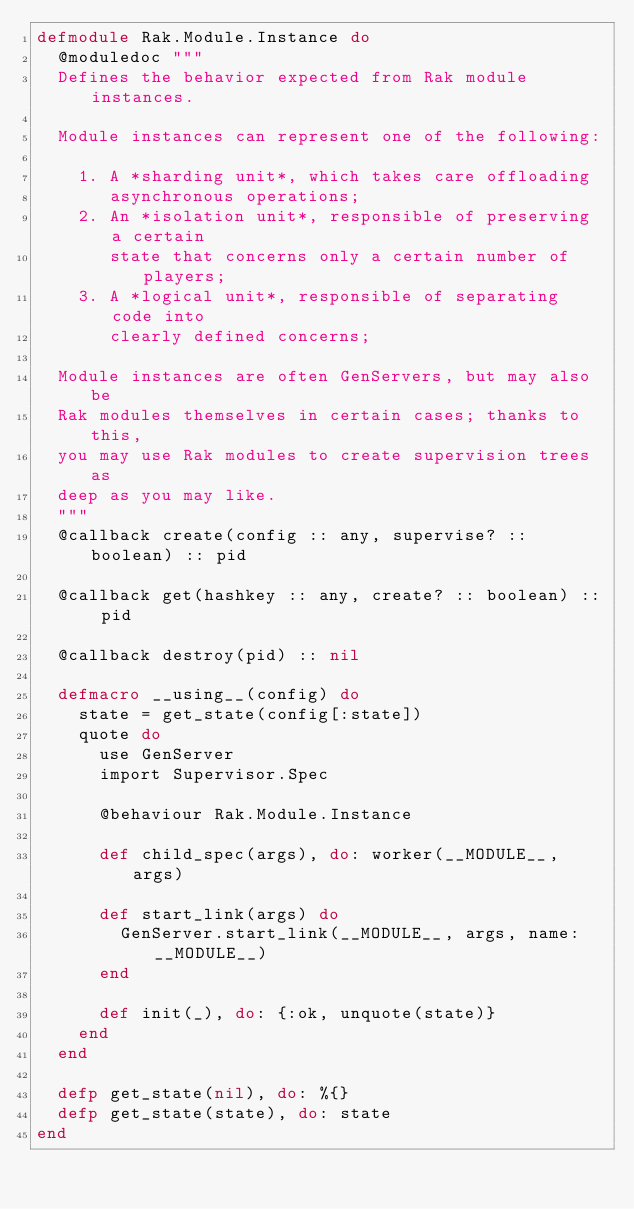<code> <loc_0><loc_0><loc_500><loc_500><_Elixir_>defmodule Rak.Module.Instance do
  @moduledoc """
  Defines the behavior expected from Rak module instances.

  Module instances can represent one of the following:

    1. A *sharding unit*, which takes care offloading
       asynchronous operations;
    2. An *isolation unit*, responsible of preserving a certain
       state that concerns only a certain number of players;
    3. A *logical unit*, responsible of separating code into
       clearly defined concerns;

  Module instances are often GenServers, but may also be
  Rak modules themselves in certain cases; thanks to this,
  you may use Rak modules to create supervision trees as
  deep as you may like.
  """
  @callback create(config :: any, supervise? :: boolean) :: pid

  @callback get(hashkey :: any, create? :: boolean) :: pid

  @callback destroy(pid) :: nil

  defmacro __using__(config) do
    state = get_state(config[:state])
    quote do
      use GenServer
      import Supervisor.Spec

      @behaviour Rak.Module.Instance

      def child_spec(args), do: worker(__MODULE__, args)

      def start_link(args) do
        GenServer.start_link(__MODULE__, args, name: __MODULE__)
      end

      def init(_), do: {:ok, unquote(state)}
    end
  end

  defp get_state(nil), do: %{}
  defp get_state(state), do: state
end
</code> 